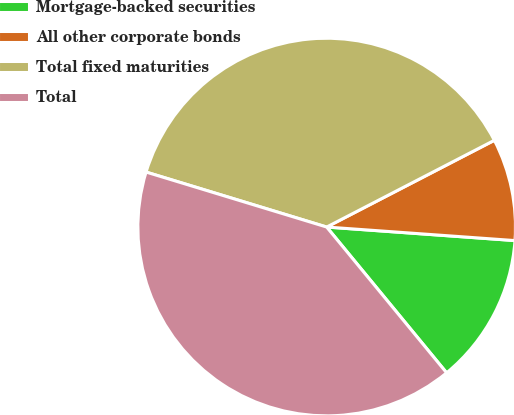<chart> <loc_0><loc_0><loc_500><loc_500><pie_chart><fcel>Mortgage-backed securities<fcel>All other corporate bonds<fcel>Total fixed maturities<fcel>Total<nl><fcel>12.9%<fcel>8.74%<fcel>37.7%<fcel>40.66%<nl></chart> 